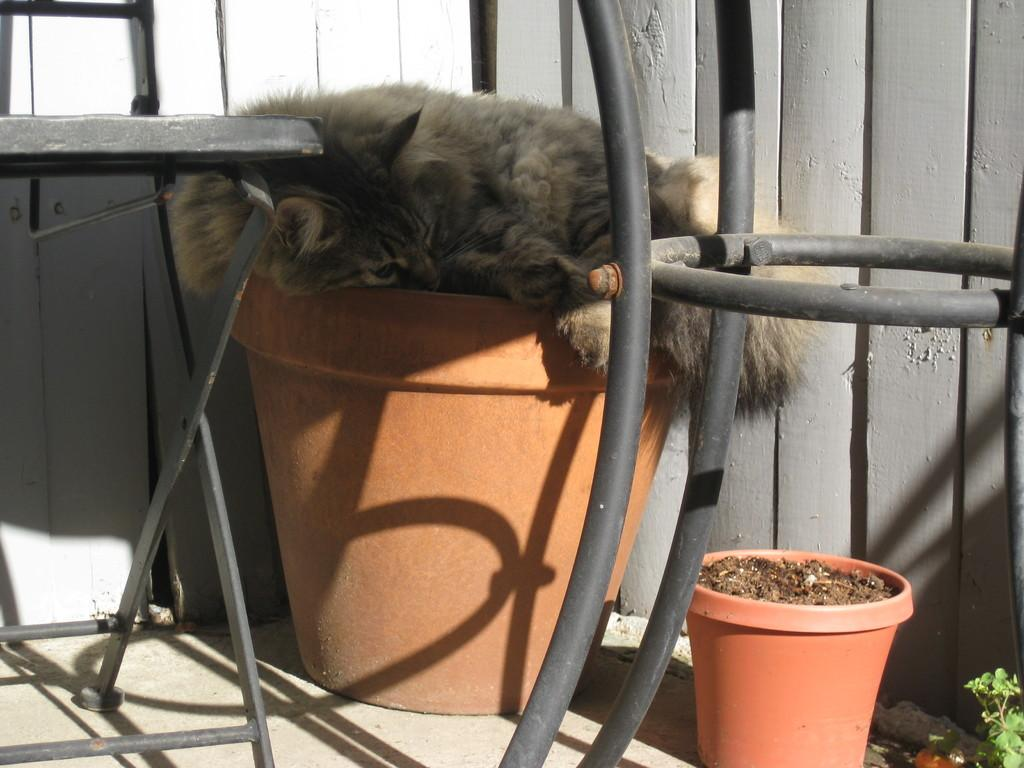What type of furniture is visible in the image? There are chairs in the image. What can be seen behind the chairs? There are plants behind the chairs. What animal is present in the image? There is a cat on a pot in the image. What is located behind the cat? There is a wall behind the cat. Can you hear the cat coughing in the image? There is no indication of sound in the image, so it is not possible to determine if the cat is coughing or not. What type of hook is attached to the wall behind the cat? There is no hook visible in the image; only the wall is present behind the cat. 